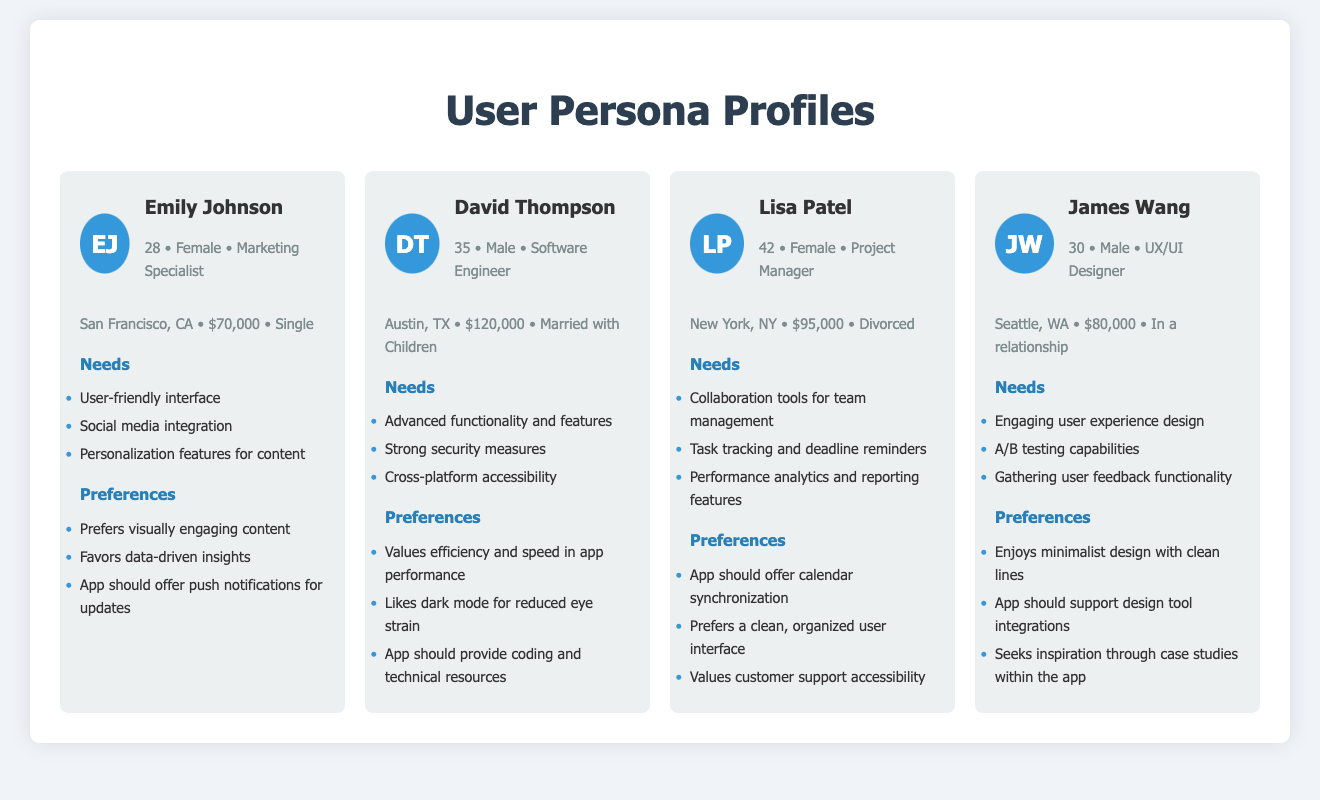What is the name of the first persona? The first persona's name, as listed in the document, is Emily Johnson.
Answer: Emily Johnson How old is David Thompson? The document states that David Thompson is 35 years old.
Answer: 35 What city does Lisa Patel reside in? According to the persona profile, Lisa Patel lives in New York, NY.
Answer: New York, NY What primary need does James Wang have? The document lists engaging user experience design as one of James Wang's primary needs.
Answer: Engaging user experience design Which persona prefers dark mode? The persona who likes dark mode, according to the document, is David Thompson.
Answer: David Thompson What salary range is indicated for Emily Johnson? The document shows that Emily Johnson earns $70,000.
Answer: $70,000 What preference does Lisa Patel have regarding customer support? Lisa Patel values customer support accessibility, as mentioned in the document.
Answer: Customer support accessibility How many personas are described in the document? The document contains a total of four distinct user personas.
Answer: Four What is the occupation of James Wang? The persona profile indicates that James Wang is a UX/UI Designer.
Answer: UX/UI Designer 